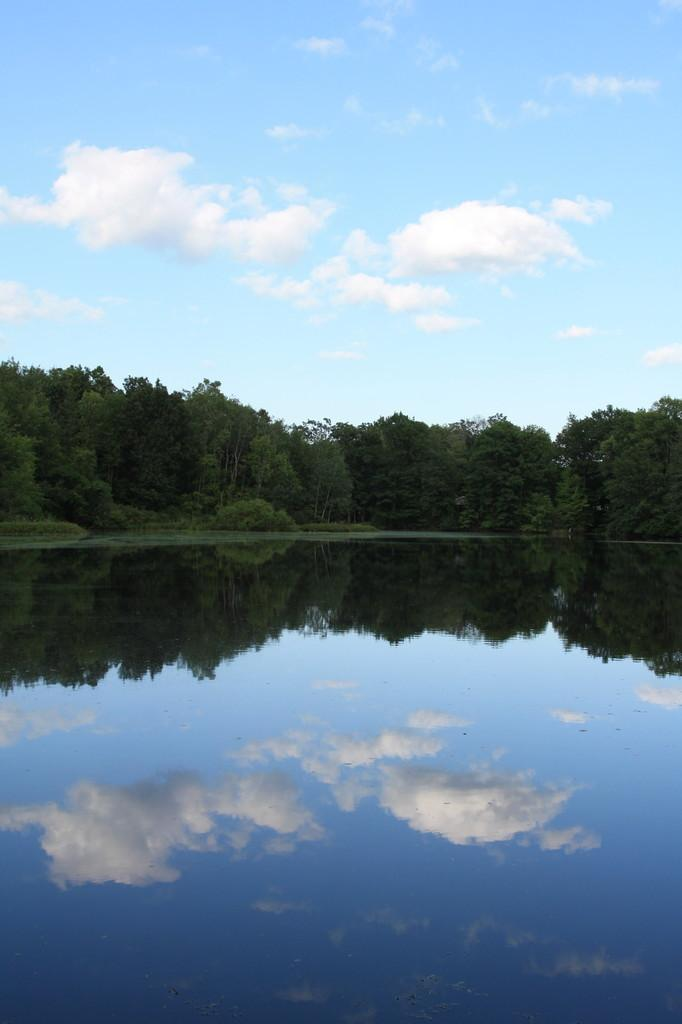What is the main feature in the center of the image? There is water in the center of the image. What type of vegetation can be seen in the image? There is grass and trees in the image. What is visible in the background of the image? The sky is visible in the image. What can be observed in the sky? Clouds are present in the sky. What type of roof can be seen in the image? There is no roof present in the image. How does the water affect the acoustics in the image? The image does not provide any information about the acoustics, as it only shows water, grass, trees, and the sky. 